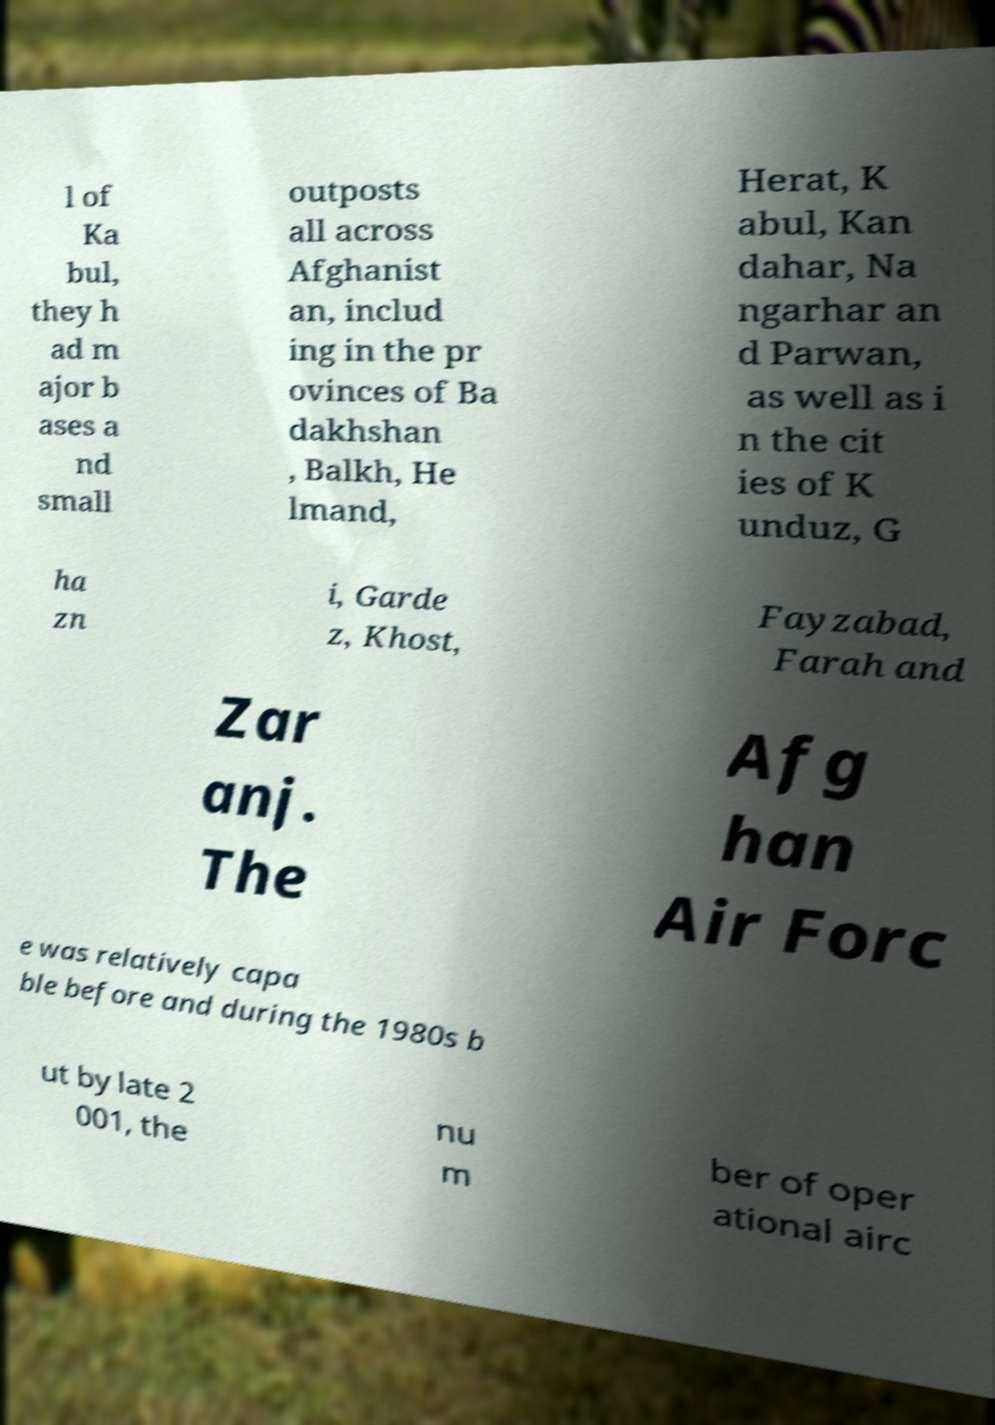Please identify and transcribe the text found in this image. l of Ka bul, they h ad m ajor b ases a nd small outposts all across Afghanist an, includ ing in the pr ovinces of Ba dakhshan , Balkh, He lmand, Herat, K abul, Kan dahar, Na ngarhar an d Parwan, as well as i n the cit ies of K unduz, G ha zn i, Garde z, Khost, Fayzabad, Farah and Zar anj. The Afg han Air Forc e was relatively capa ble before and during the 1980s b ut by late 2 001, the nu m ber of oper ational airc 